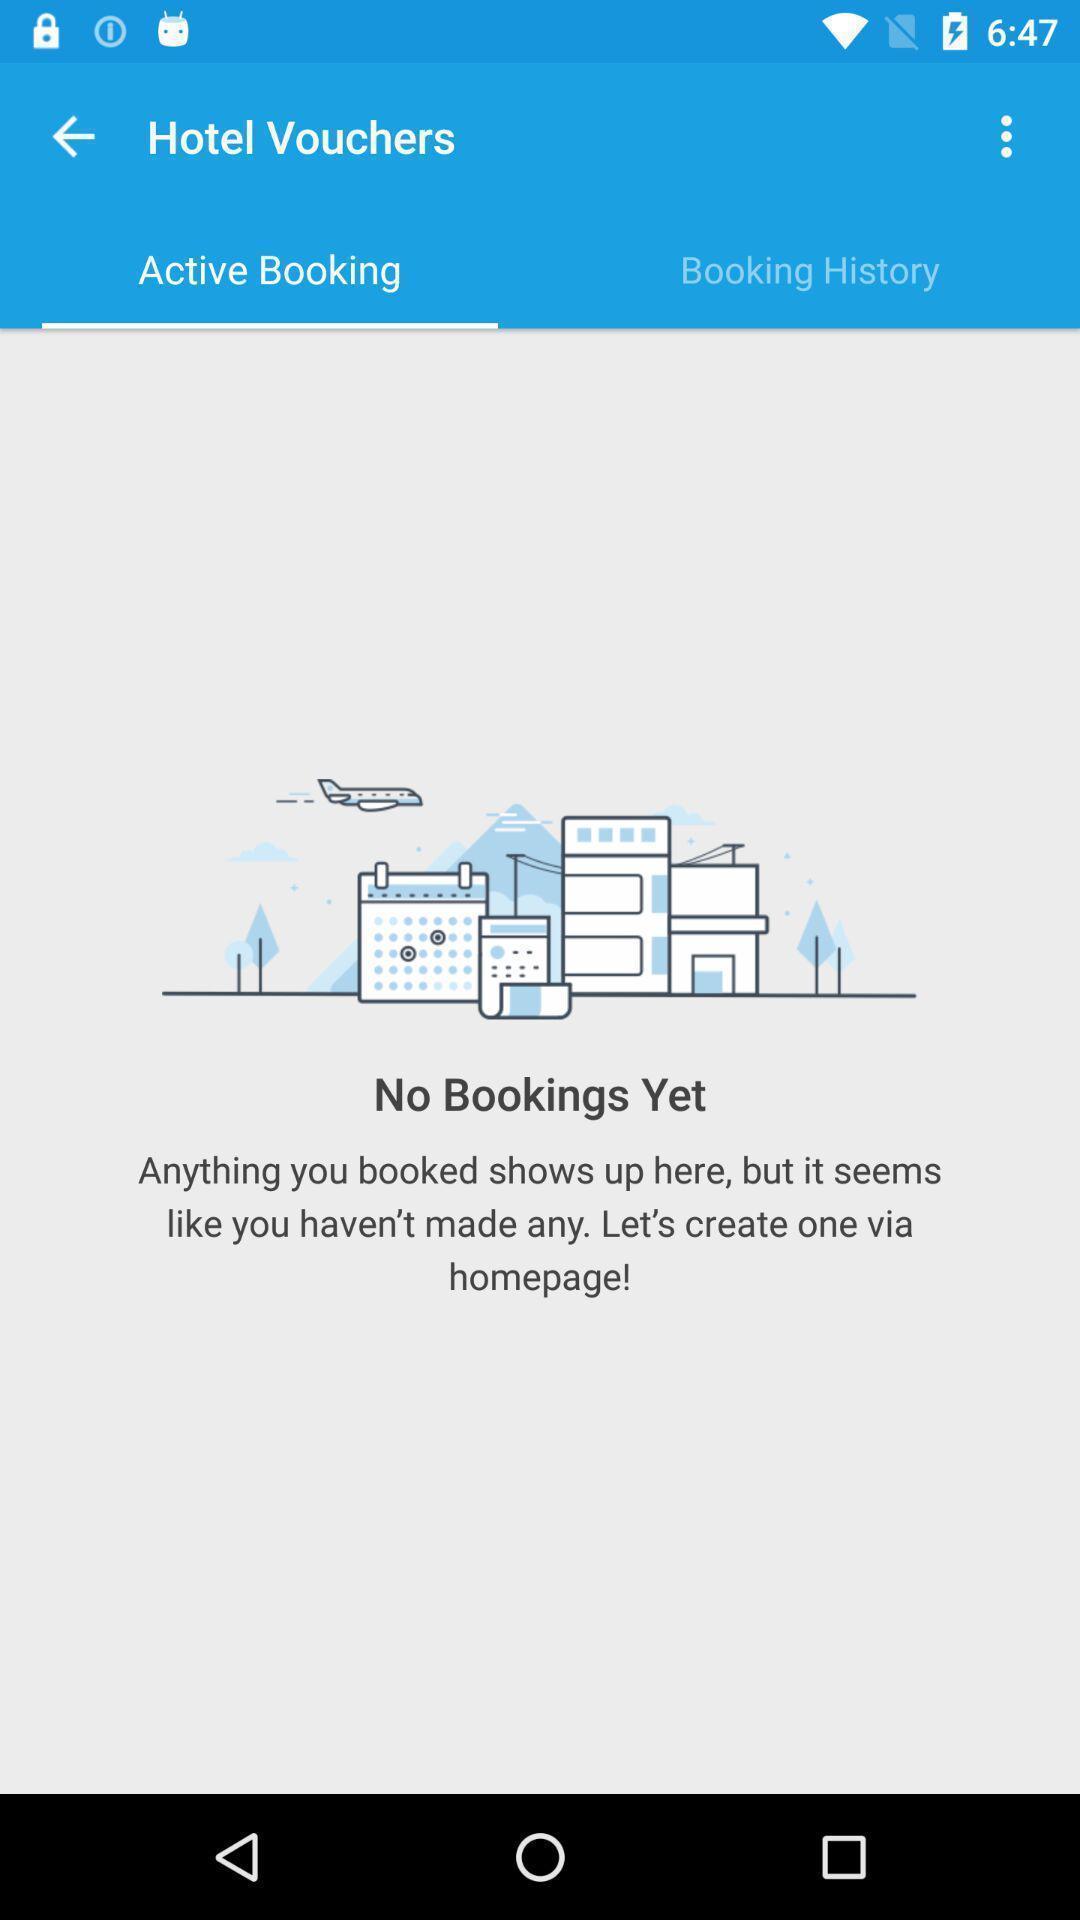Provide a textual representation of this image. Page showing information related to hotel bookings with multiple options. 